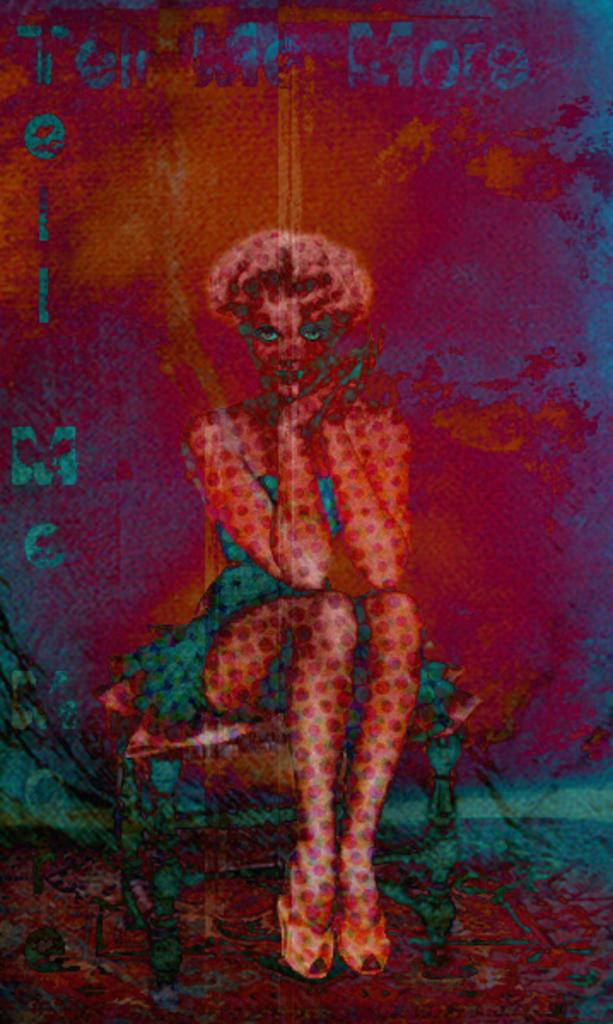What type of artwork is depicted in the image? The image is a painting. Can you describe the main subject of the painting? There is a lady in the center of the painting. Are there any additional elements in the painting besides the lady? Yes, there is text present in the painting. How many thrones can be seen in the painting? There are no thrones present in the painting. What number is written in the text within the painting? The provided facts do not give information about the specific text within the painting, so we cannot determine the number written in it. 